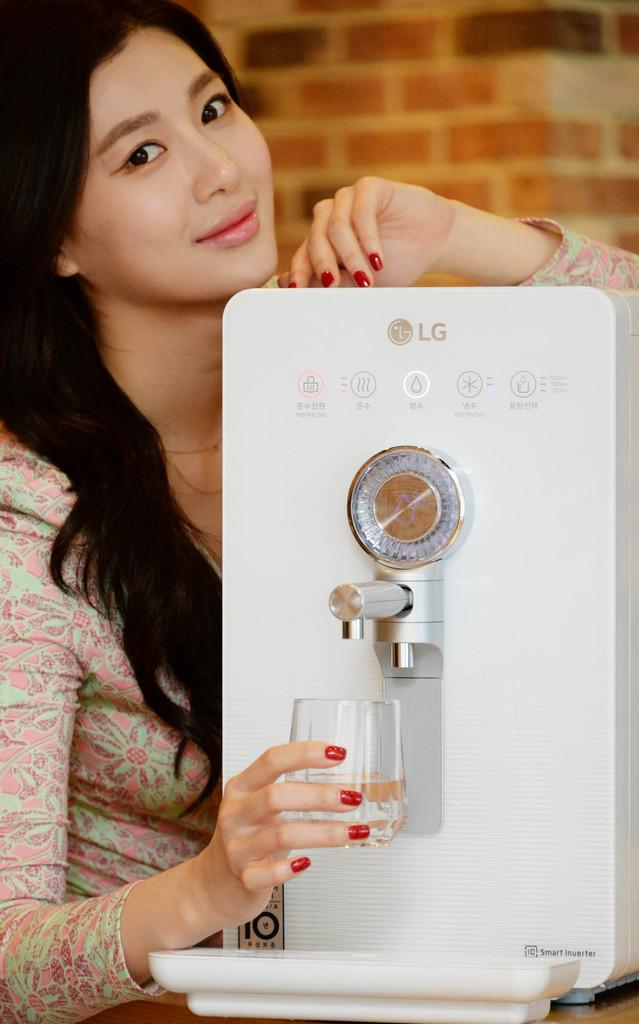<image>
Offer a succinct explanation of the picture presented. a woman displaying an LG water filter named Smart Inverter 